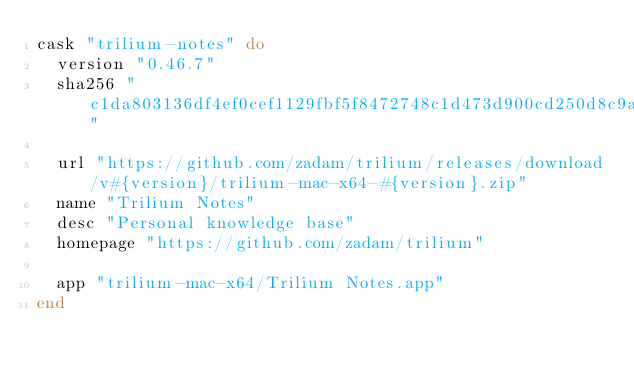Convert code to text. <code><loc_0><loc_0><loc_500><loc_500><_Ruby_>cask "trilium-notes" do
  version "0.46.7"
  sha256 "c1da803136df4ef0cef1129fbf5f8472748c1d473d900cd250d8c9a61f11cbea"

  url "https://github.com/zadam/trilium/releases/download/v#{version}/trilium-mac-x64-#{version}.zip"
  name "Trilium Notes"
  desc "Personal knowledge base"
  homepage "https://github.com/zadam/trilium"

  app "trilium-mac-x64/Trilium Notes.app"
end
</code> 